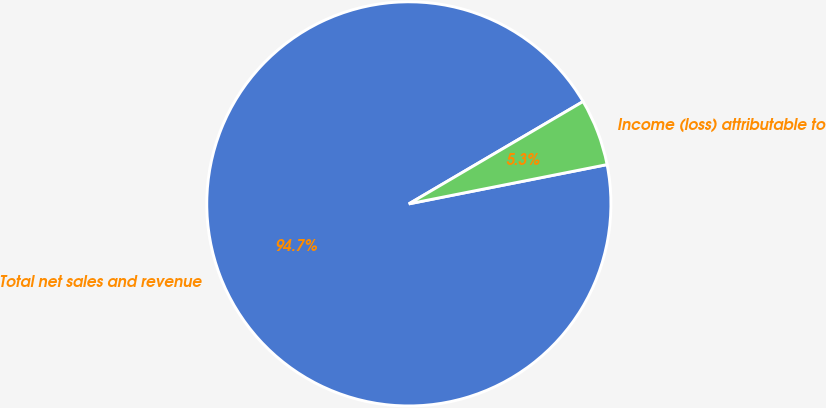Convert chart to OTSL. <chart><loc_0><loc_0><loc_500><loc_500><pie_chart><fcel>Total net sales and revenue<fcel>Income (loss) attributable to<nl><fcel>94.66%<fcel>5.34%<nl></chart> 